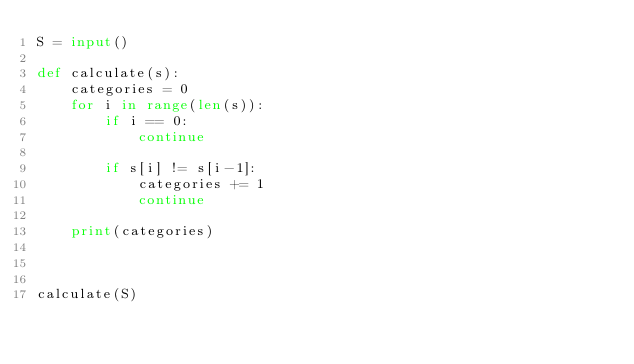<code> <loc_0><loc_0><loc_500><loc_500><_Python_>S = input()

def calculate(s):
    categories = 0
    for i in range(len(s)):
        if i == 0:
            continue

        if s[i] != s[i-1]:
            categories += 1
            continue

    print(categories)



calculate(S)</code> 